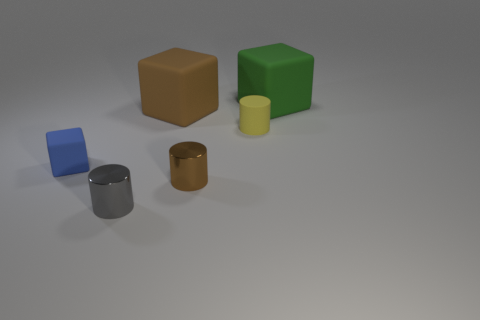What is the size of the metal object that is right of the large rubber thing to the left of the cube that is behind the big brown cube?
Offer a very short reply. Small. Are there more tiny metallic cylinders than big green things?
Make the answer very short. Yes. Are the big object that is in front of the large green matte object and the tiny gray object made of the same material?
Your response must be concise. No. Is the number of big yellow blocks less than the number of tiny shiny cylinders?
Provide a short and direct response. Yes. Is there a gray shiny thing to the left of the thing in front of the metallic cylinder that is right of the gray thing?
Provide a succinct answer. No. There is a shiny thing behind the gray metallic cylinder; does it have the same shape as the large brown object?
Ensure brevity in your answer.  No. Are there more big blocks that are in front of the gray metal cylinder than tiny gray metallic cylinders?
Your response must be concise. No. Does the cylinder behind the tiny blue rubber object have the same color as the small cube?
Make the answer very short. No. Is there any other thing that has the same color as the tiny rubber cylinder?
Offer a very short reply. No. What is the color of the small cylinder that is left of the shiny thing that is right of the large object that is to the left of the green cube?
Ensure brevity in your answer.  Gray. 